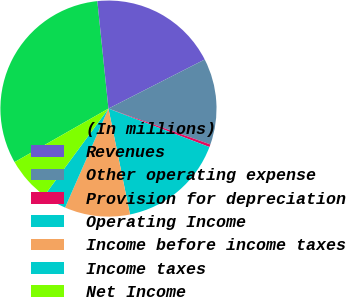Convert chart. <chart><loc_0><loc_0><loc_500><loc_500><pie_chart><fcel>(In millions)<fcel>Revenues<fcel>Other operating expense<fcel>Provision for depreciation<fcel>Operating Income<fcel>Income before income taxes<fcel>Income taxes<fcel>Net Income<nl><fcel>31.61%<fcel>19.13%<fcel>12.89%<fcel>0.41%<fcel>16.01%<fcel>9.77%<fcel>3.53%<fcel>6.65%<nl></chart> 